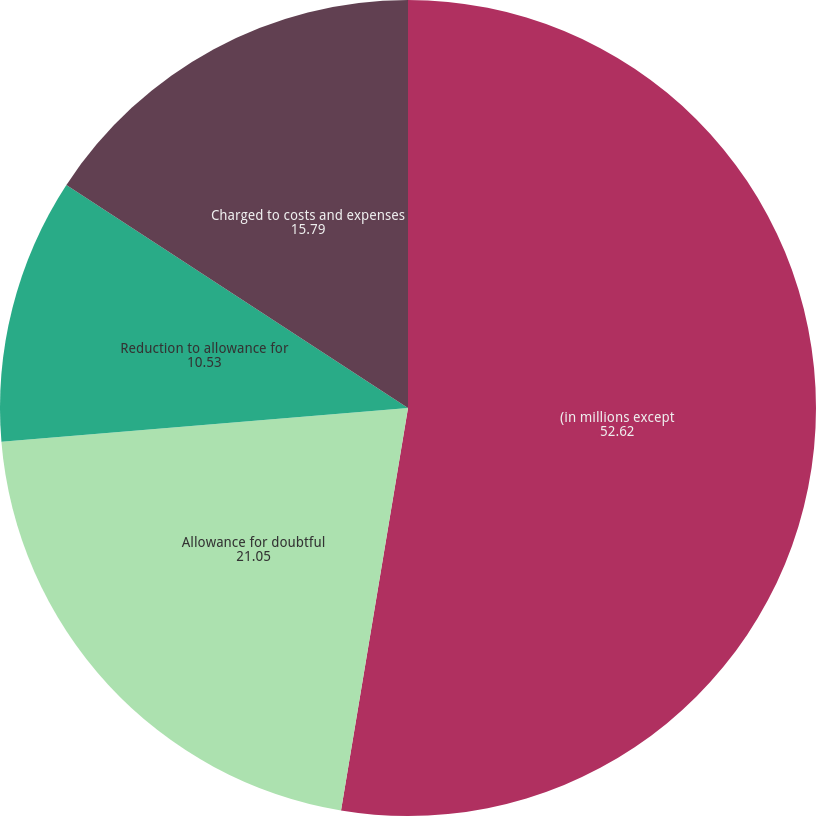Convert chart to OTSL. <chart><loc_0><loc_0><loc_500><loc_500><pie_chart><fcel>(in millions except<fcel>Allowance for doubtful<fcel>Reduction to allowance for<fcel>Charged to costs and expenses<fcel>Allowance as a percentage of<nl><fcel>52.62%<fcel>21.05%<fcel>10.53%<fcel>15.79%<fcel>0.0%<nl></chart> 